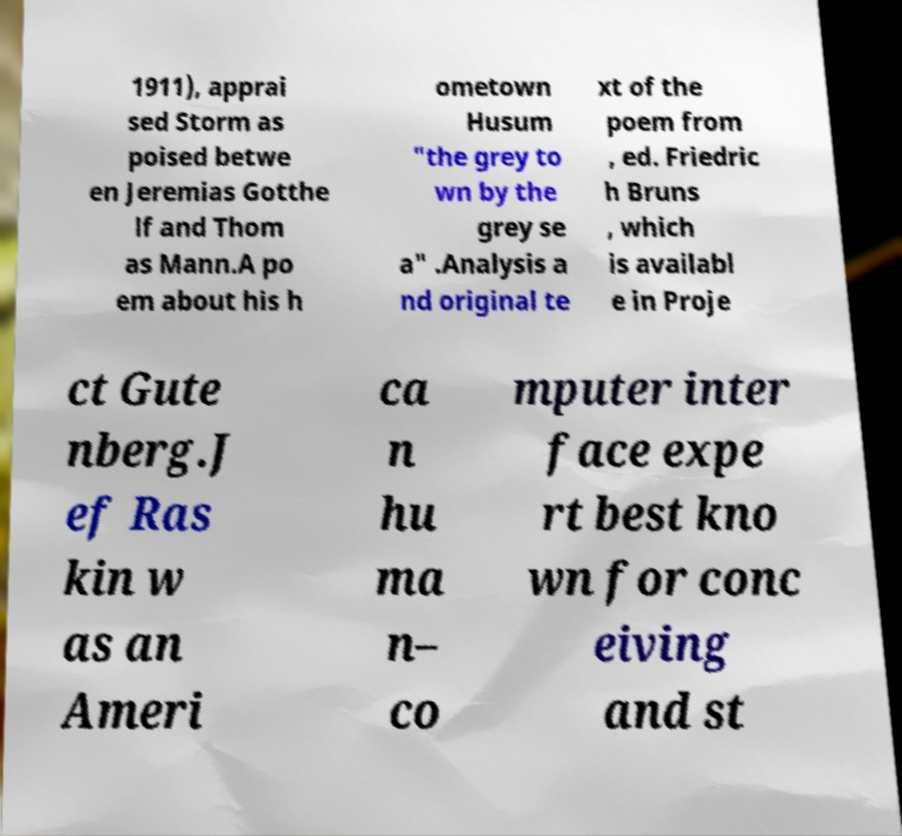Please read and relay the text visible in this image. What does it say? 1911), apprai sed Storm as poised betwe en Jeremias Gotthe lf and Thom as Mann.A po em about his h ometown Husum "the grey to wn by the grey se a" .Analysis a nd original te xt of the poem from , ed. Friedric h Bruns , which is availabl e in Proje ct Gute nberg.J ef Ras kin w as an Ameri ca n hu ma n– co mputer inter face expe rt best kno wn for conc eiving and st 